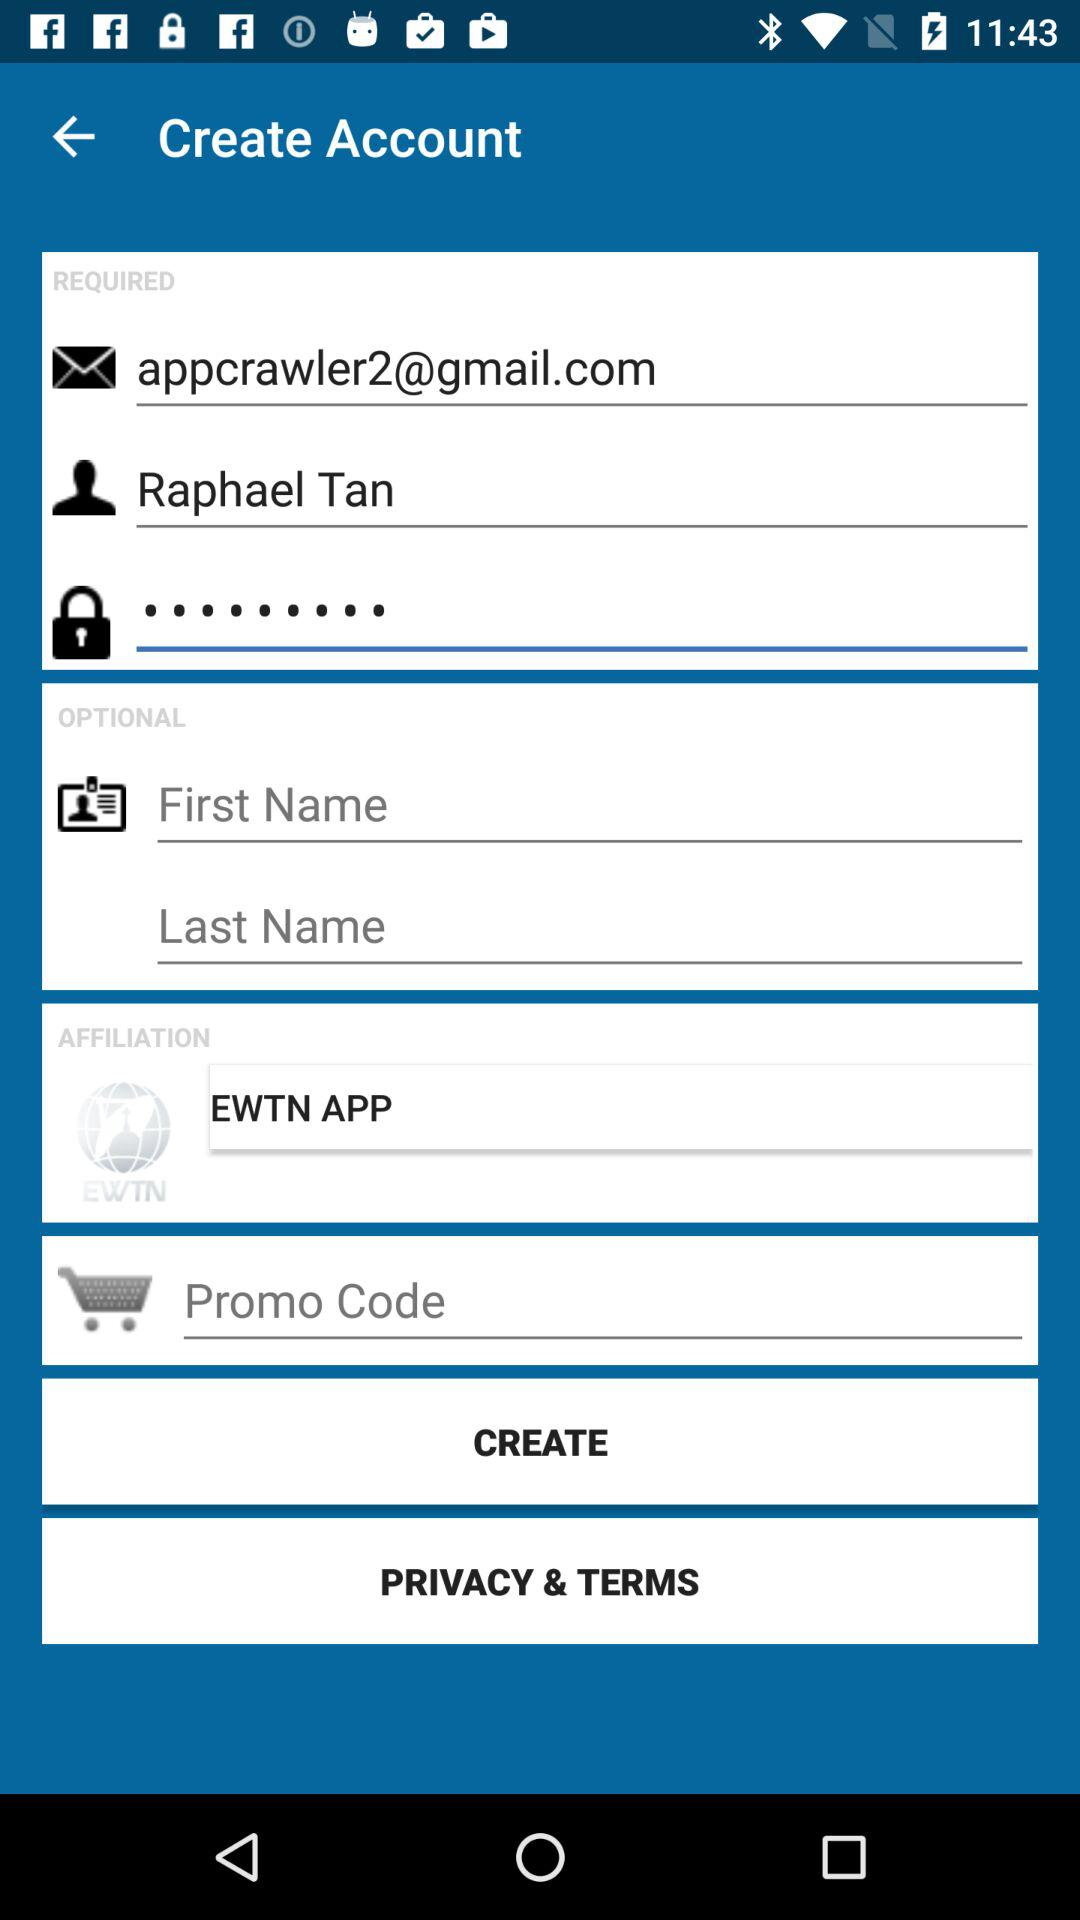What is the email address? The email address is appcrawler2@gmail.com. 